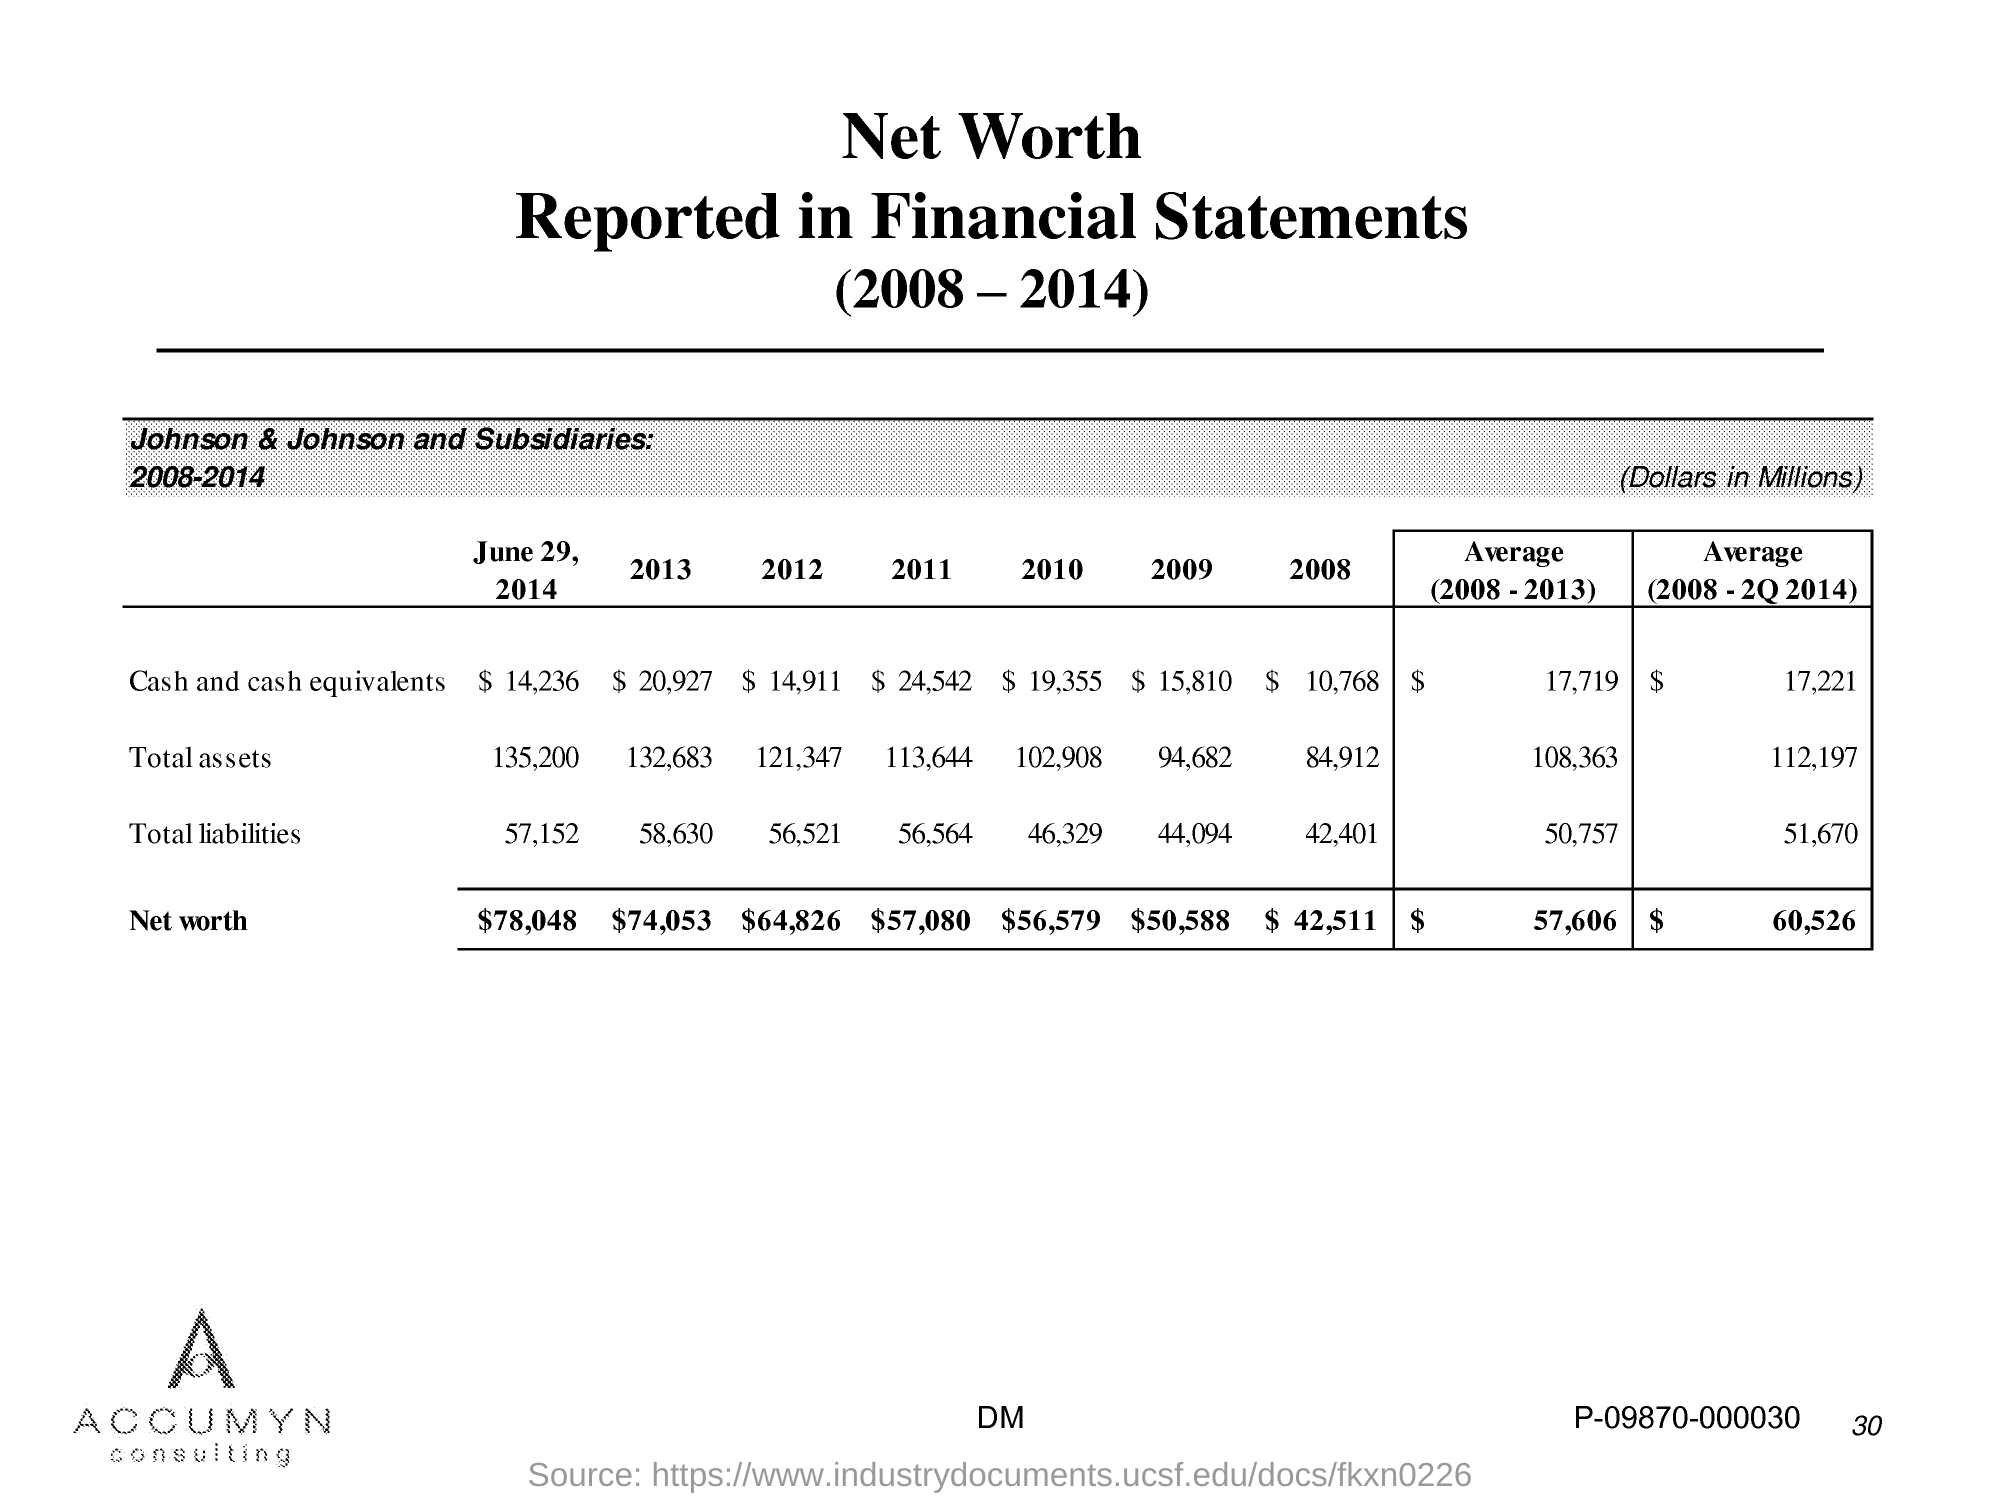what is the total assets in 2011?
 113,644 